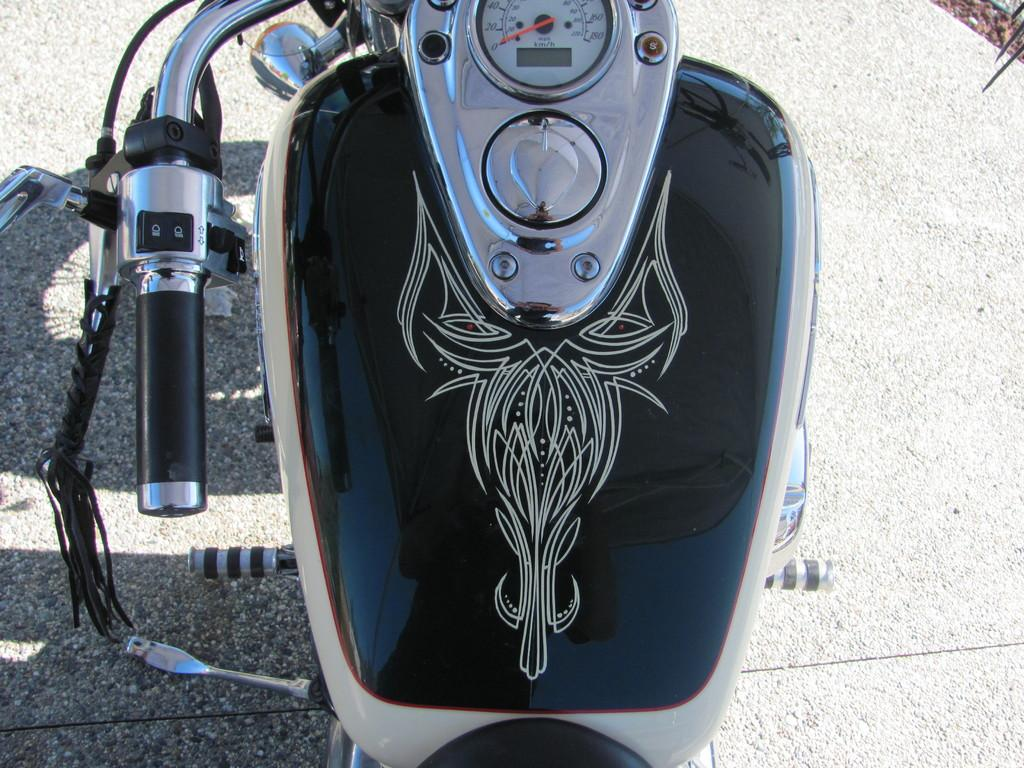What is the main object in the image? There is a bike in the image. Where is the bike located? The bike is parked on a road. What feature does the bike have? The bike has a speedometer. What is the color of the background in the image? The background of the image is gray in color. Can you see the tail of the animal in the image? There is no animal or tail present in the image; it features a bike parked on a road. How does the bike control the speed of the rider in the image? The image does not show the bike in motion, so it is not possible to determine how the speed is controlled. 